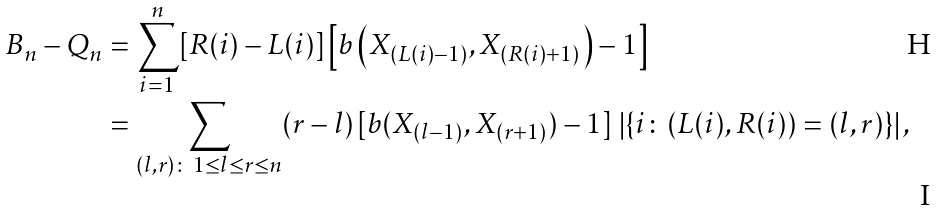<formula> <loc_0><loc_0><loc_500><loc_500>B _ { n } - Q _ { n } & = \sum _ { i = 1 } ^ { n } [ R ( i ) - L ( i ) ] \left [ b \left ( X _ { ( L ( i ) - 1 ) } , X _ { ( R ( i ) + 1 ) } \right ) - 1 \right ] \\ & = \sum _ { ( l , r ) \colon \, 1 \leq l \leq r \leq n } ( r - l ) \, [ b ( X _ { ( l - 1 ) } , X _ { ( r + 1 ) } ) - 1 ] \, \left | \{ i \colon ( L ( i ) , R ( i ) ) = ( l , r ) \} \right | ,</formula> 